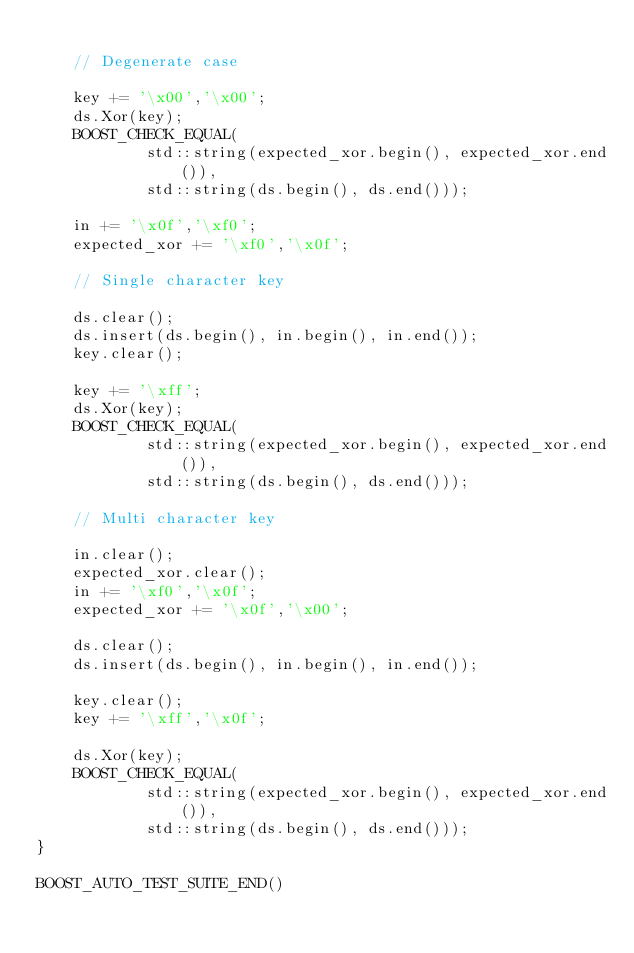<code> <loc_0><loc_0><loc_500><loc_500><_C++_>
    // Degenerate case
    
    key += '\x00','\x00';
    ds.Xor(key);
    BOOST_CHECK_EQUAL(
            std::string(expected_xor.begin(), expected_xor.end()), 
            std::string(ds.begin(), ds.end()));

    in += '\x0f','\xf0';
    expected_xor += '\xf0','\x0f';
    
    // Single character key

    ds.clear();
    ds.insert(ds.begin(), in.begin(), in.end());
    key.clear();

    key += '\xff';
    ds.Xor(key);
    BOOST_CHECK_EQUAL(
            std::string(expected_xor.begin(), expected_xor.end()), 
            std::string(ds.begin(), ds.end())); 
    
    // Multi character key

    in.clear();
    expected_xor.clear();
    in += '\xf0','\x0f';
    expected_xor += '\x0f','\x00';
                        
    ds.clear();
    ds.insert(ds.begin(), in.begin(), in.end());

    key.clear();
    key += '\xff','\x0f';

    ds.Xor(key);
    BOOST_CHECK_EQUAL(
            std::string(expected_xor.begin(), expected_xor.end()), 
            std::string(ds.begin(), ds.end()));  
}         

BOOST_AUTO_TEST_SUITE_END()
</code> 